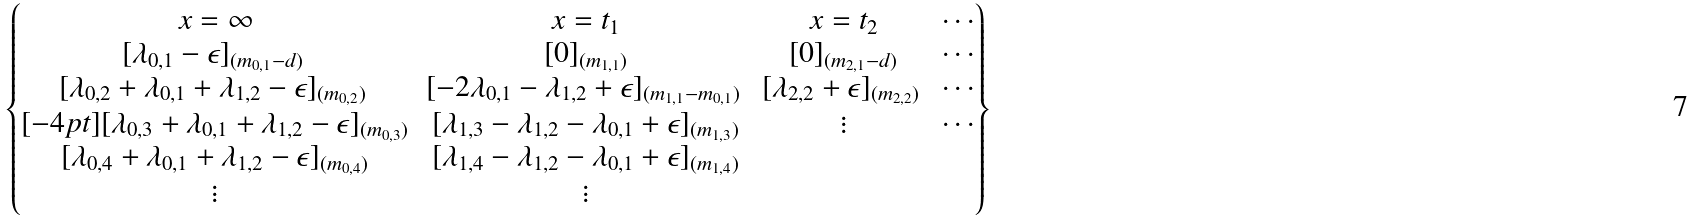<formula> <loc_0><loc_0><loc_500><loc_500>\begin{Bmatrix} x = \infty & x = t _ { 1 } & x = t _ { 2 } & \cdots \\ [ \lambda _ { 0 , 1 } - \epsilon ] _ { ( m _ { 0 , 1 } - d ) } \, & [ 0 ] _ { ( m _ { 1 , 1 } ) } & [ 0 ] _ { ( m _ { 2 , 1 } - d ) } & \cdots \\ [ \lambda _ { 0 , 2 } + \lambda _ { 0 , 1 } + \lambda _ { 1 , 2 } - \epsilon ] _ { ( m _ { 0 , 2 } ) } \, & [ - 2 \lambda _ { 0 , 1 } - \lambda _ { 1 , 2 } + \epsilon ] _ { ( m _ { 1 , 1 } - m _ { 0 , 1 } ) } \, & [ \lambda _ { 2 , 2 } + \epsilon ] _ { ( m _ { 2 , 2 } ) } \, & \cdots \\ [ - 4 p t ] [ \lambda _ { 0 , 3 } + \lambda _ { 0 , 1 } + \lambda _ { 1 , 2 } - \epsilon ] _ { ( m _ { 0 , 3 } ) } & [ \lambda _ { 1 , 3 } - \lambda _ { 1 , 2 } - \lambda _ { 0 , 1 } + \epsilon ] _ { ( m _ { 1 , 3 } ) } & \vdots & \cdots \\ [ \lambda _ { 0 , 4 } + \lambda _ { 0 , 1 } + \lambda _ { 1 , 2 } - \epsilon ] _ { ( m _ { 0 , 4 } ) } & [ \lambda _ { 1 , 4 } - \lambda _ { 1 , 2 } - \lambda _ { 0 , 1 } + \epsilon ] _ { ( m _ { 1 , 4 } ) } \\ \vdots & \vdots \end{Bmatrix}</formula> 